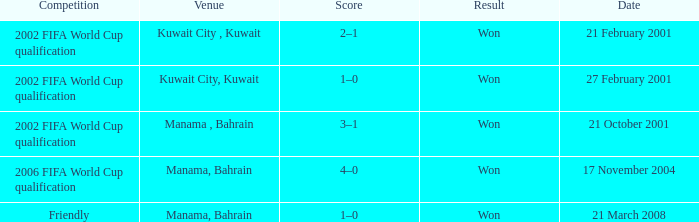What was the final score of the Friendly Competition in Manama, Bahrain? 1–0. Can you give me this table as a dict? {'header': ['Competition', 'Venue', 'Score', 'Result', 'Date'], 'rows': [['2002 FIFA World Cup qualification', 'Kuwait City , Kuwait', '2–1', 'Won', '21 February 2001'], ['2002 FIFA World Cup qualification', 'Kuwait City, Kuwait', '1–0', 'Won', '27 February 2001'], ['2002 FIFA World Cup qualification', 'Manama , Bahrain', '3–1', 'Won', '21 October 2001'], ['2006 FIFA World Cup qualification', 'Manama, Bahrain', '4–0', 'Won', '17 November 2004'], ['Friendly', 'Manama, Bahrain', '1–0', 'Won', '21 March 2008']]} 